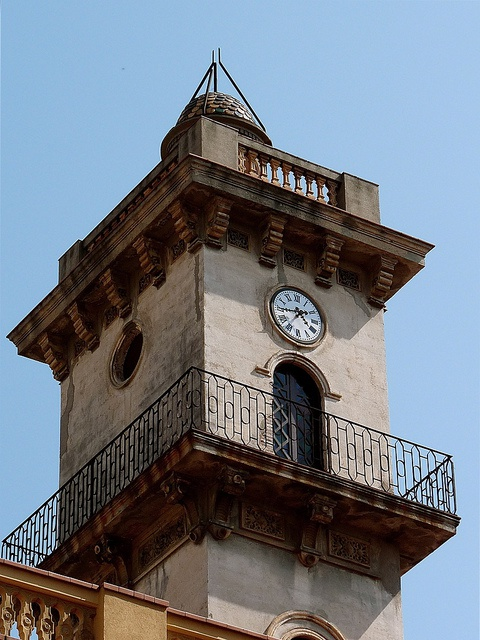Describe the objects in this image and their specific colors. I can see a clock in darkgray, lightgray, black, and gray tones in this image. 